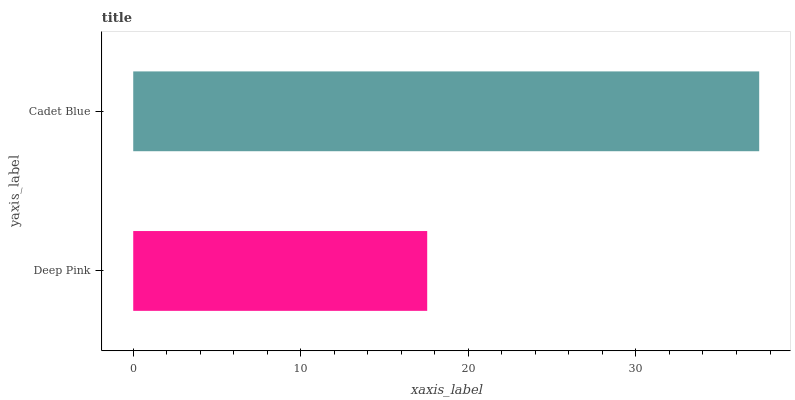Is Deep Pink the minimum?
Answer yes or no. Yes. Is Cadet Blue the maximum?
Answer yes or no. Yes. Is Cadet Blue the minimum?
Answer yes or no. No. Is Cadet Blue greater than Deep Pink?
Answer yes or no. Yes. Is Deep Pink less than Cadet Blue?
Answer yes or no. Yes. Is Deep Pink greater than Cadet Blue?
Answer yes or no. No. Is Cadet Blue less than Deep Pink?
Answer yes or no. No. Is Cadet Blue the high median?
Answer yes or no. Yes. Is Deep Pink the low median?
Answer yes or no. Yes. Is Deep Pink the high median?
Answer yes or no. No. Is Cadet Blue the low median?
Answer yes or no. No. 